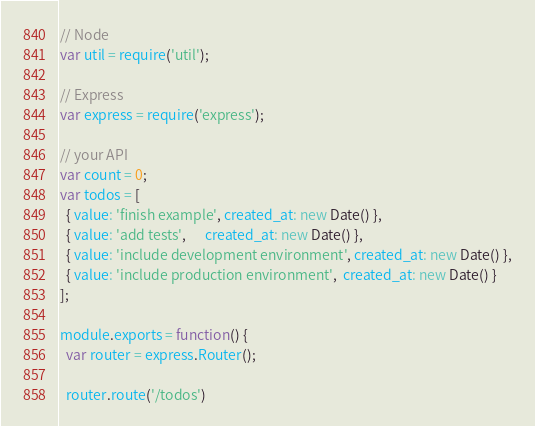Convert code to text. <code><loc_0><loc_0><loc_500><loc_500><_JavaScript_>// Node
var util = require('util');

// Express
var express = require('express');

// your API
var count = 0;
var todos = [
  { value: 'finish example', created_at: new Date() },
  { value: 'add tests',      created_at: new Date() },
  { value: 'include development environment', created_at: new Date() },
  { value: 'include production environment',  created_at: new Date() }
];

module.exports = function() {
  var router = express.Router();

  router.route('/todos')</code> 